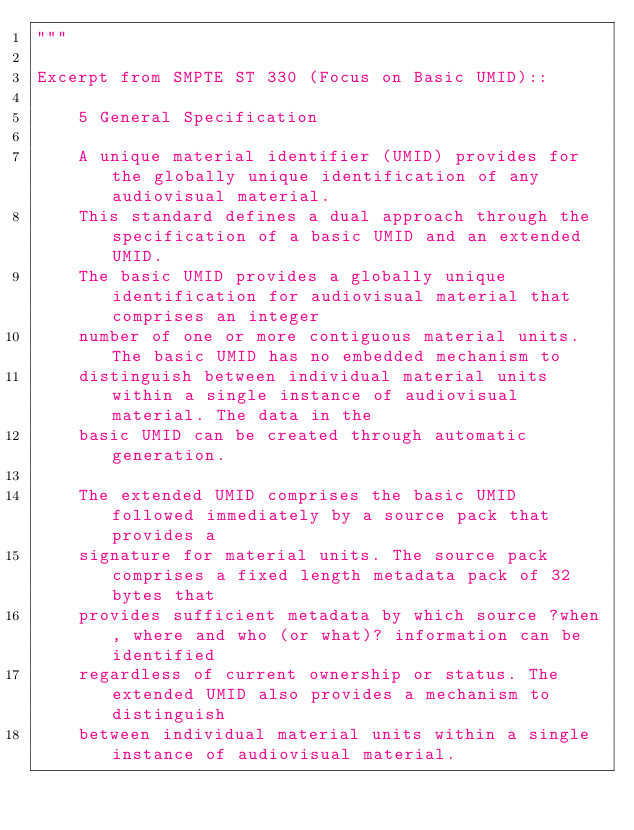Convert code to text. <code><loc_0><loc_0><loc_500><loc_500><_Python_>"""

Excerpt from SMPTE ST 330 (Focus on Basic UMID)::

    5 General Specification

    A unique material identifier (UMID) provides for the globally unique identification of any audiovisual material.
    This standard defines a dual approach through the specification of a basic UMID and an extended UMID.
    The basic UMID provides a globally unique identification for audiovisual material that comprises an integer
    number of one or more contiguous material units. The basic UMID has no embedded mechanism to
    distinguish between individual material units within a single instance of audiovisual material. The data in the
    basic UMID can be created through automatic generation.

    The extended UMID comprises the basic UMID followed immediately by a source pack that provides a
    signature for material units. The source pack comprises a fixed length metadata pack of 32 bytes that
    provides sufficient metadata by which source ?when, where and who (or what)? information can be identified
    regardless of current ownership or status. The extended UMID also provides a mechanism to distinguish
    between individual material units within a single instance of audiovisual material.
</code> 